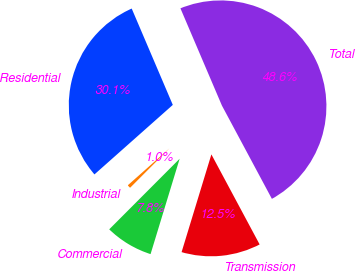Convert chart. <chart><loc_0><loc_0><loc_500><loc_500><pie_chart><fcel>Residential<fcel>Industrial<fcel>Commercial<fcel>Transmission<fcel>Total<nl><fcel>30.13%<fcel>0.97%<fcel>7.77%<fcel>12.54%<fcel>48.59%<nl></chart> 